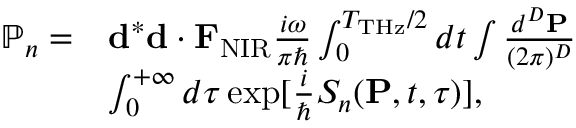Convert formula to latex. <formula><loc_0><loc_0><loc_500><loc_500>\begin{array} { r l } { \mathbb { P } _ { n } = } & { { d } ^ { * } { d } \cdot { F } _ { N I R } \frac { i \omega } { \pi } \int _ { 0 } ^ { T _ { T H z } / 2 } d t \int \frac { d ^ { D } { P } } { ( 2 \pi ) ^ { D } } } \\ & { \int _ { 0 } ^ { + \infty } d \tau \exp [ { \frac { i } { } S _ { n } ( { P } , t , \tau ) } ] , } \end{array}</formula> 